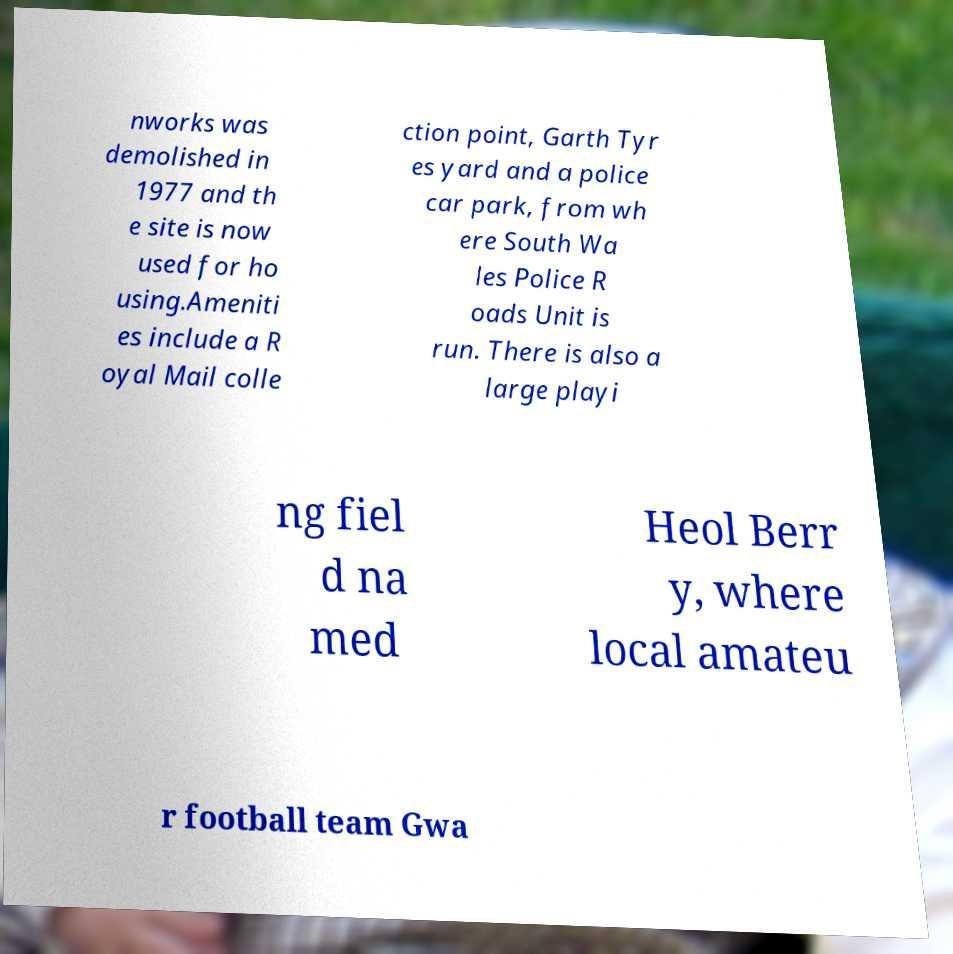Could you extract and type out the text from this image? nworks was demolished in 1977 and th e site is now used for ho using.Ameniti es include a R oyal Mail colle ction point, Garth Tyr es yard and a police car park, from wh ere South Wa les Police R oads Unit is run. There is also a large playi ng fiel d na med Heol Berr y, where local amateu r football team Gwa 